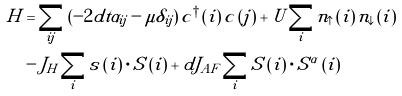<formula> <loc_0><loc_0><loc_500><loc_500>H & = \sum _ { i j } \left ( - 2 d t \alpha _ { i j } - \mu \delta _ { i j } \right ) c ^ { \dagger } \left ( i \right ) c \left ( j \right ) + U \sum _ { i } n _ { \uparrow } \left ( i \right ) n _ { \downarrow } \left ( i \right ) \\ & - J _ { H } \sum _ { i } s \left ( i \right ) \cdot S \left ( i \right ) + d J _ { A F } \sum _ { i } S \left ( i \right ) \cdot S ^ { \alpha } \left ( i \right )</formula> 